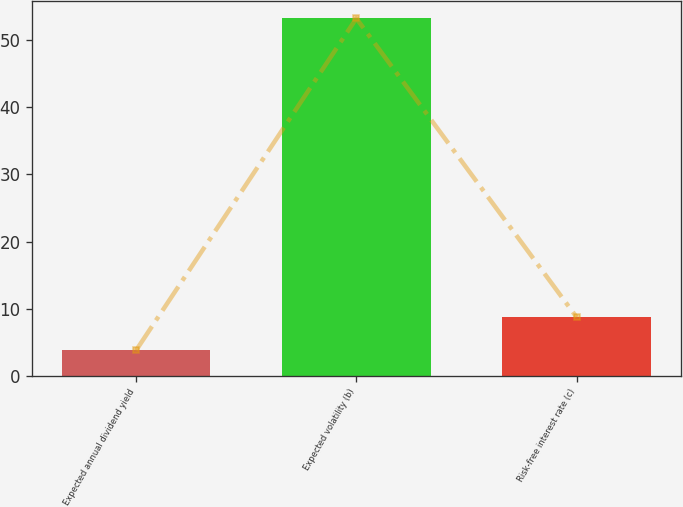<chart> <loc_0><loc_0><loc_500><loc_500><bar_chart><fcel>Expected annual dividend yield<fcel>Expected volatility (b)<fcel>Risk-free interest rate (c)<nl><fcel>3.77<fcel>53.27<fcel>8.72<nl></chart> 